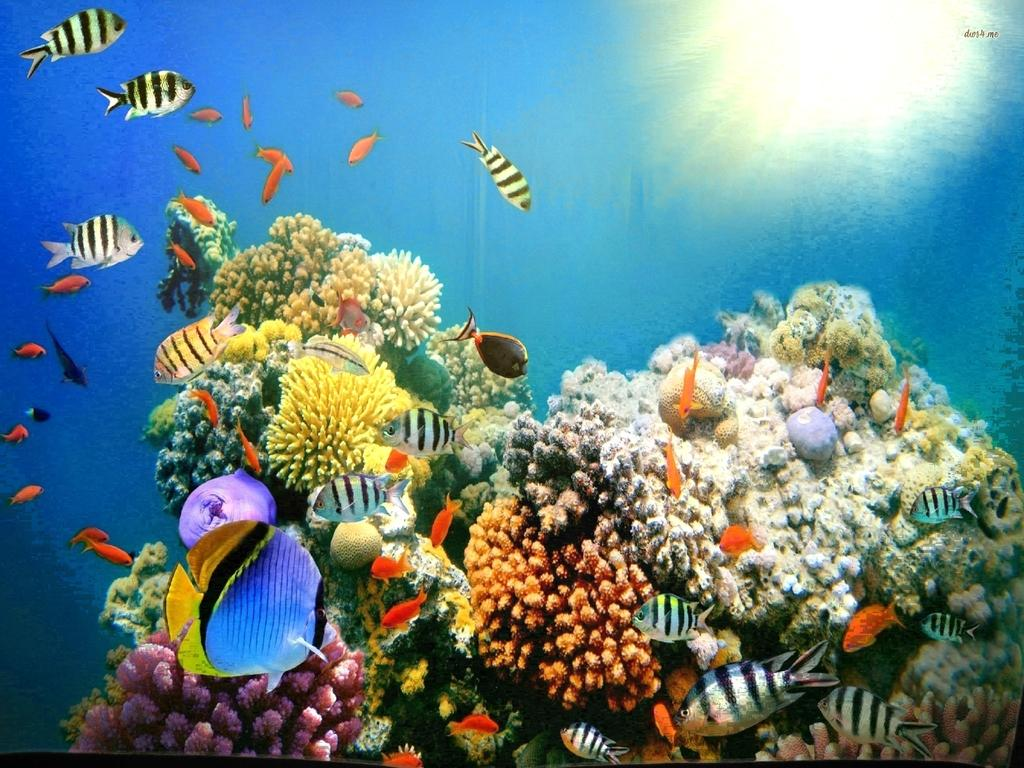What type of plants are present in the image? There are aquatic plants in the image. What other living organisms can be seen in the image? There are colorful fish in the image. What colors are used in the background of the image? The background of the image is in blue and white colors. What type of skin condition can be seen on the fish in the image? There is no indication of any skin condition on the fish in the image, as they appear to be healthy and colorful. 